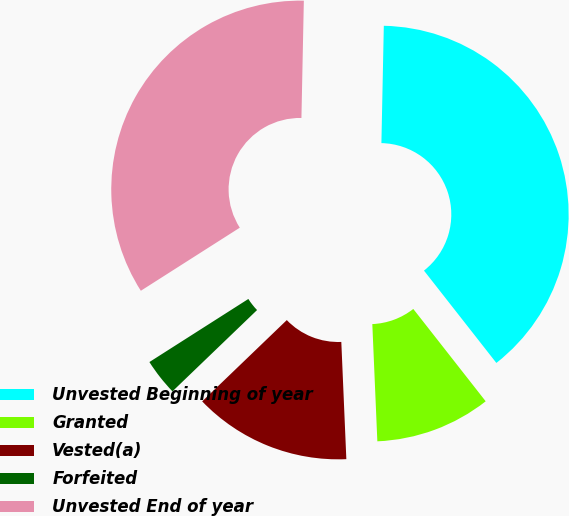<chart> <loc_0><loc_0><loc_500><loc_500><pie_chart><fcel>Unvested Beginning of year<fcel>Granted<fcel>Vested(a)<fcel>Forfeited<fcel>Unvested End of year<nl><fcel>39.09%<fcel>9.9%<fcel>13.5%<fcel>3.15%<fcel>34.36%<nl></chart> 